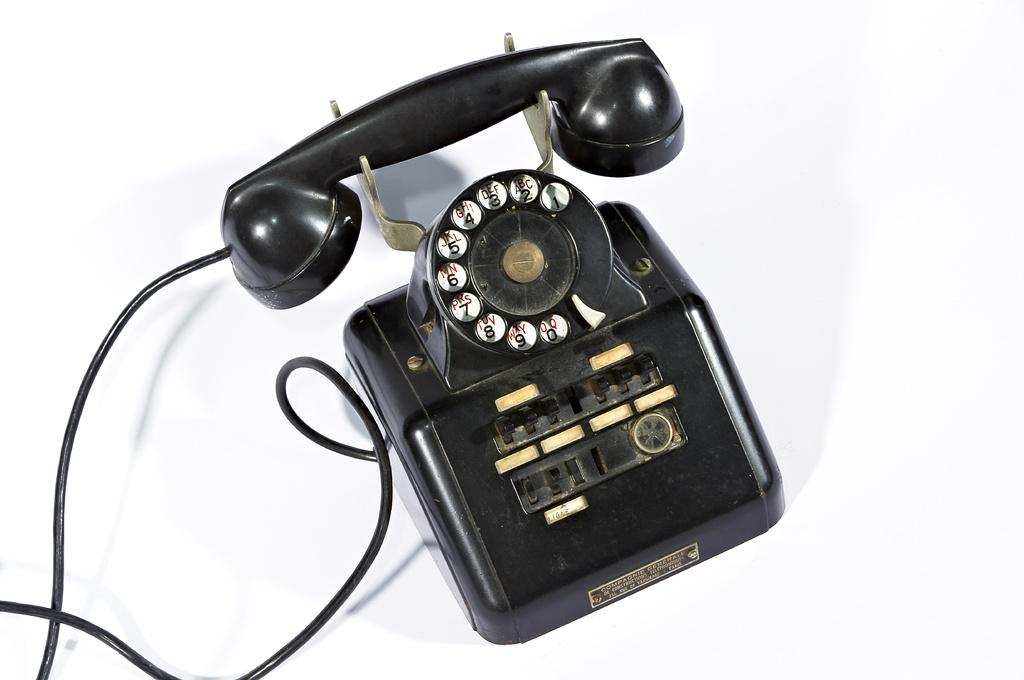<image>
Summarize the visual content of the image. A very old fashioned telehone; the first number at the bottom is zero. 